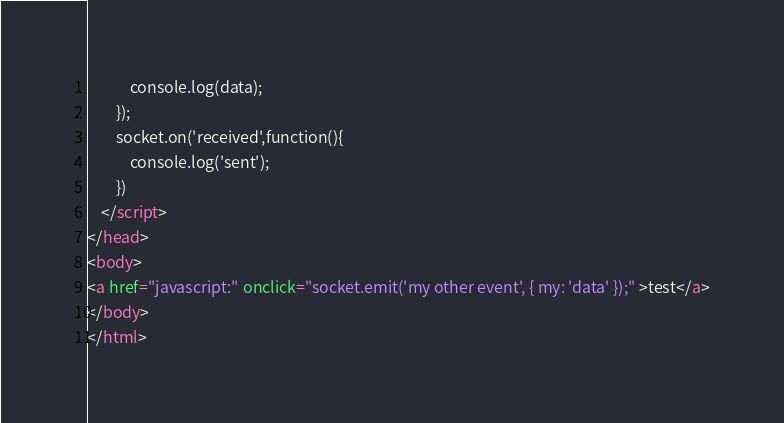Convert code to text. <code><loc_0><loc_0><loc_500><loc_500><_HTML_>            console.log(data);
        });
        socket.on('received',function(){
            console.log('sent');
        })
    </script>
</head>
<body>
<a href="javascript:" onclick="socket.emit('my other event', { my: 'data' });" >test</a>
</body>
</html></code> 